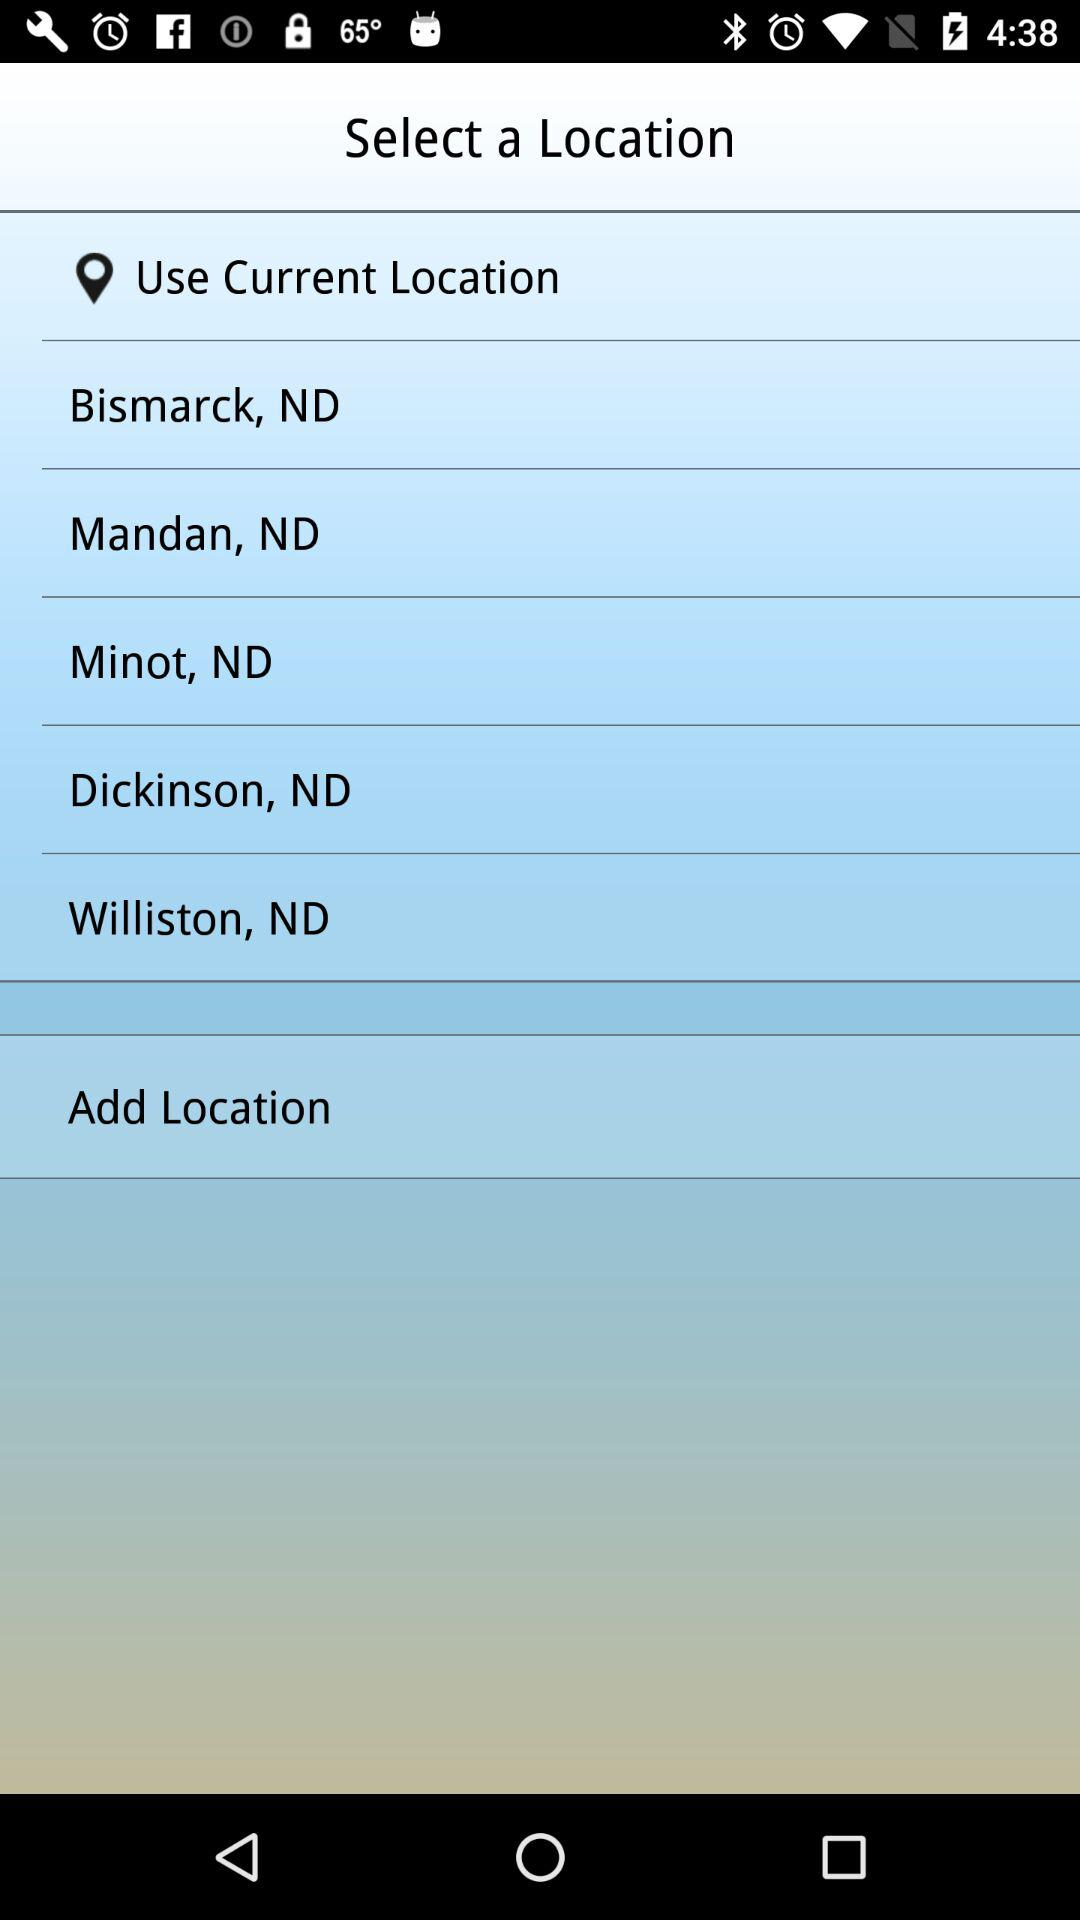How many locations are available to select from?
Answer the question using a single word or phrase. 6 